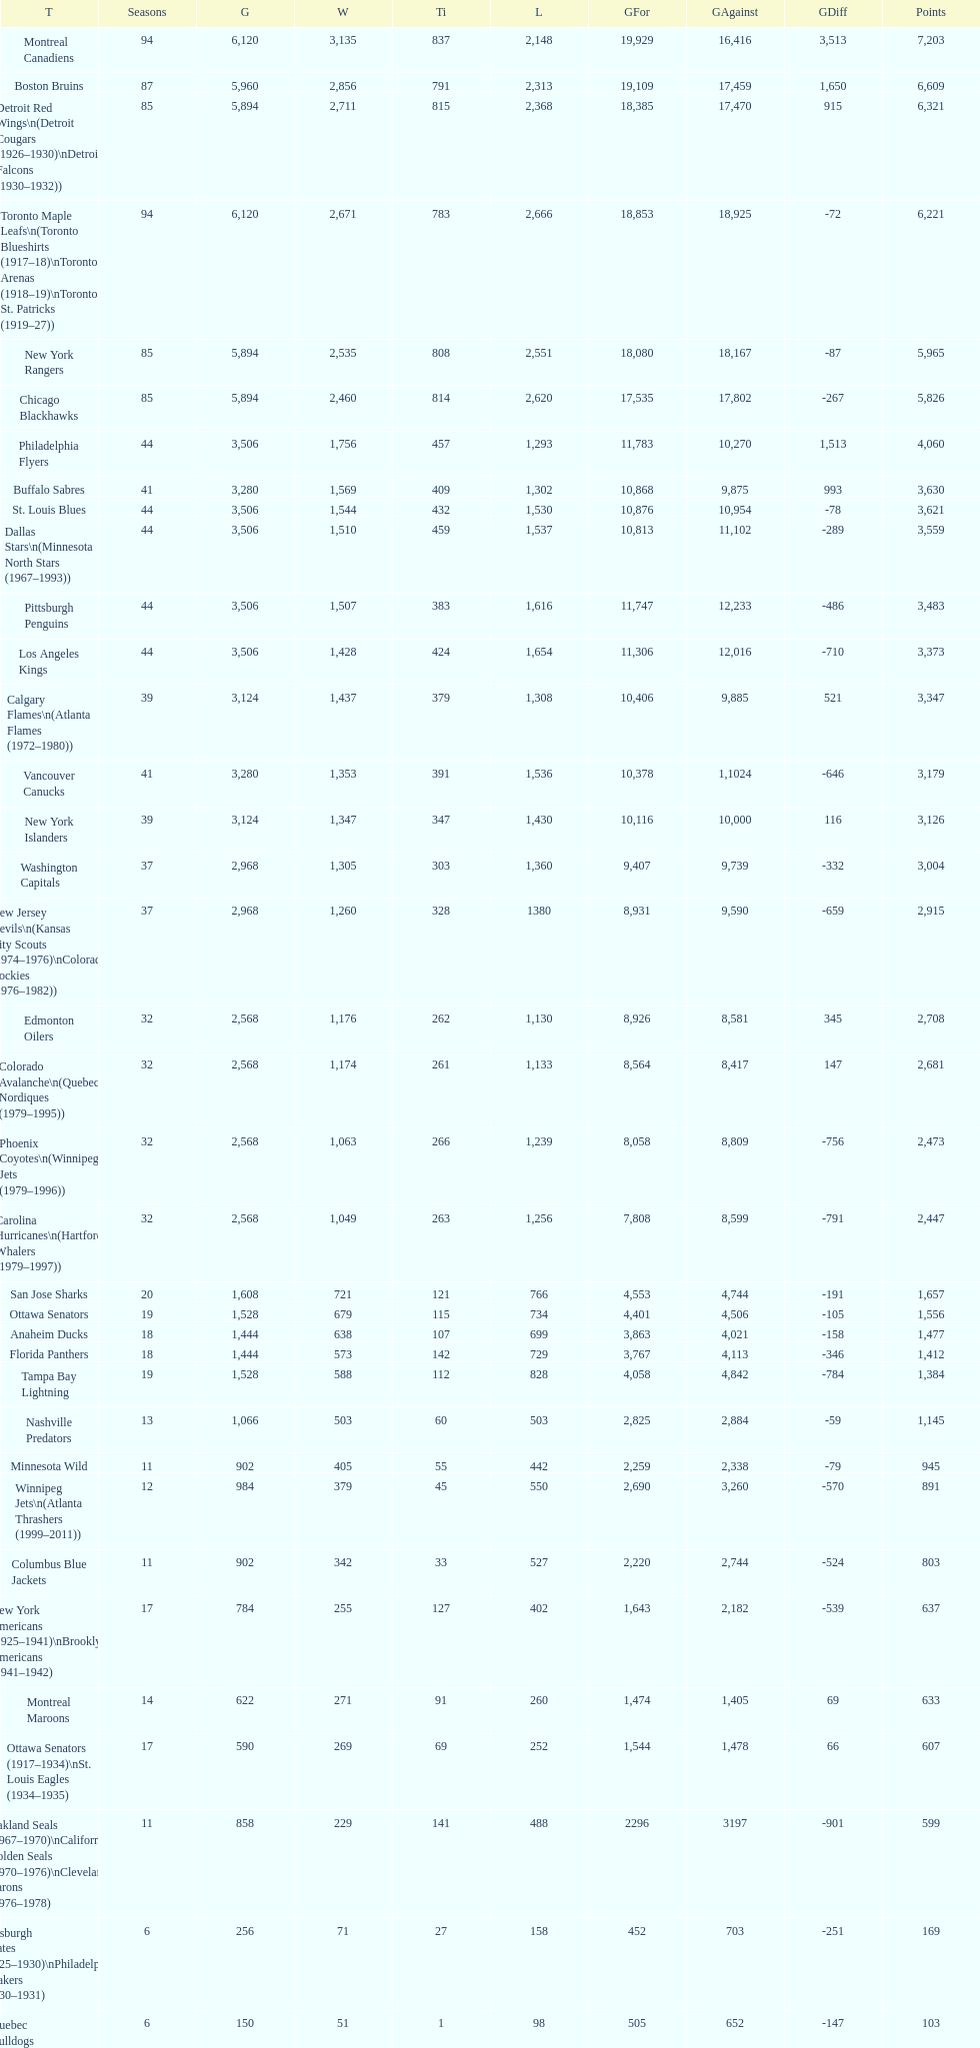How many losses do the st. louis blues have? 1,530. 